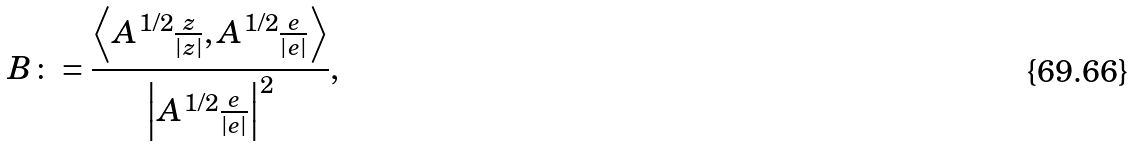Convert formula to latex. <formula><loc_0><loc_0><loc_500><loc_500>B \colon = \frac { \left \langle A ^ { 1 / 2 } \frac { z } { | z | } , A ^ { 1 / 2 } \frac { e } { | e | } \right \rangle } { \left | A ^ { 1 / 2 } \frac { e } { | e | } \right | ^ { 2 } } ,</formula> 